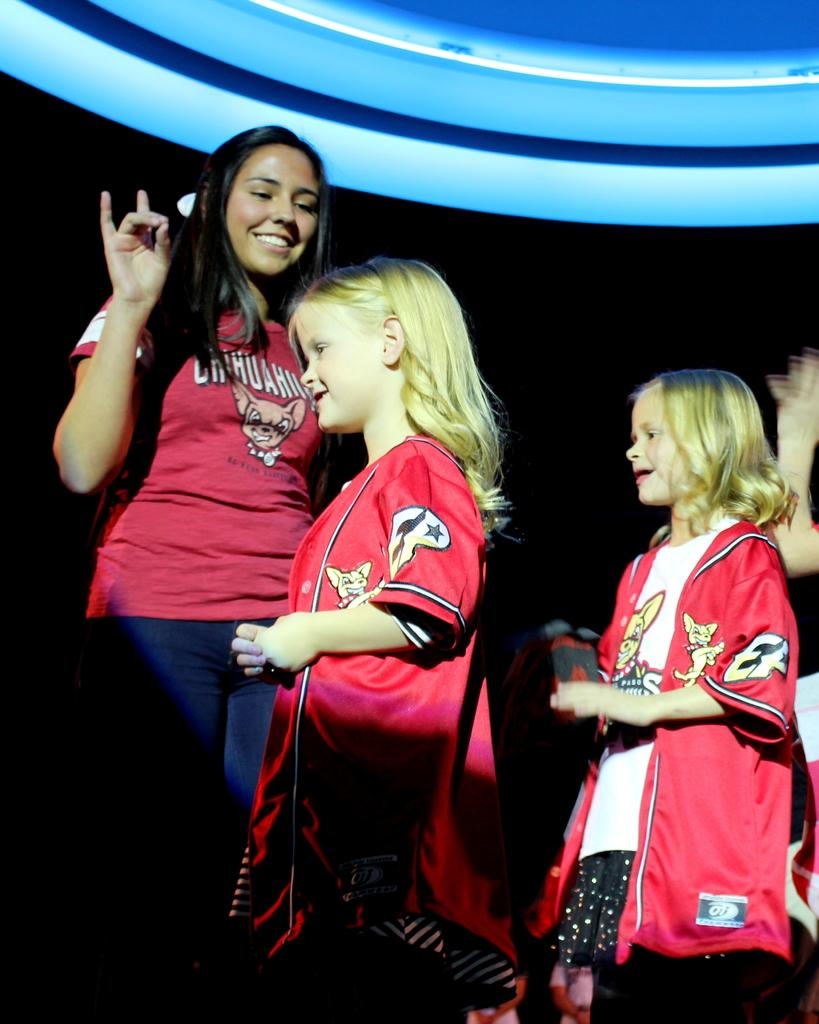What is the woman doing in the image? The woman is standing and smiling in the image. Can you describe the lighting in the image? There is a blue light in the image. How many girls are in the image? There are two girls standing and smiling in the image. What type of rice can be seen in the image? There is no rice present in the image. Is the woman celebrating her birthday in the image? There is no indication in the image that the woman is celebrating her birthday. 